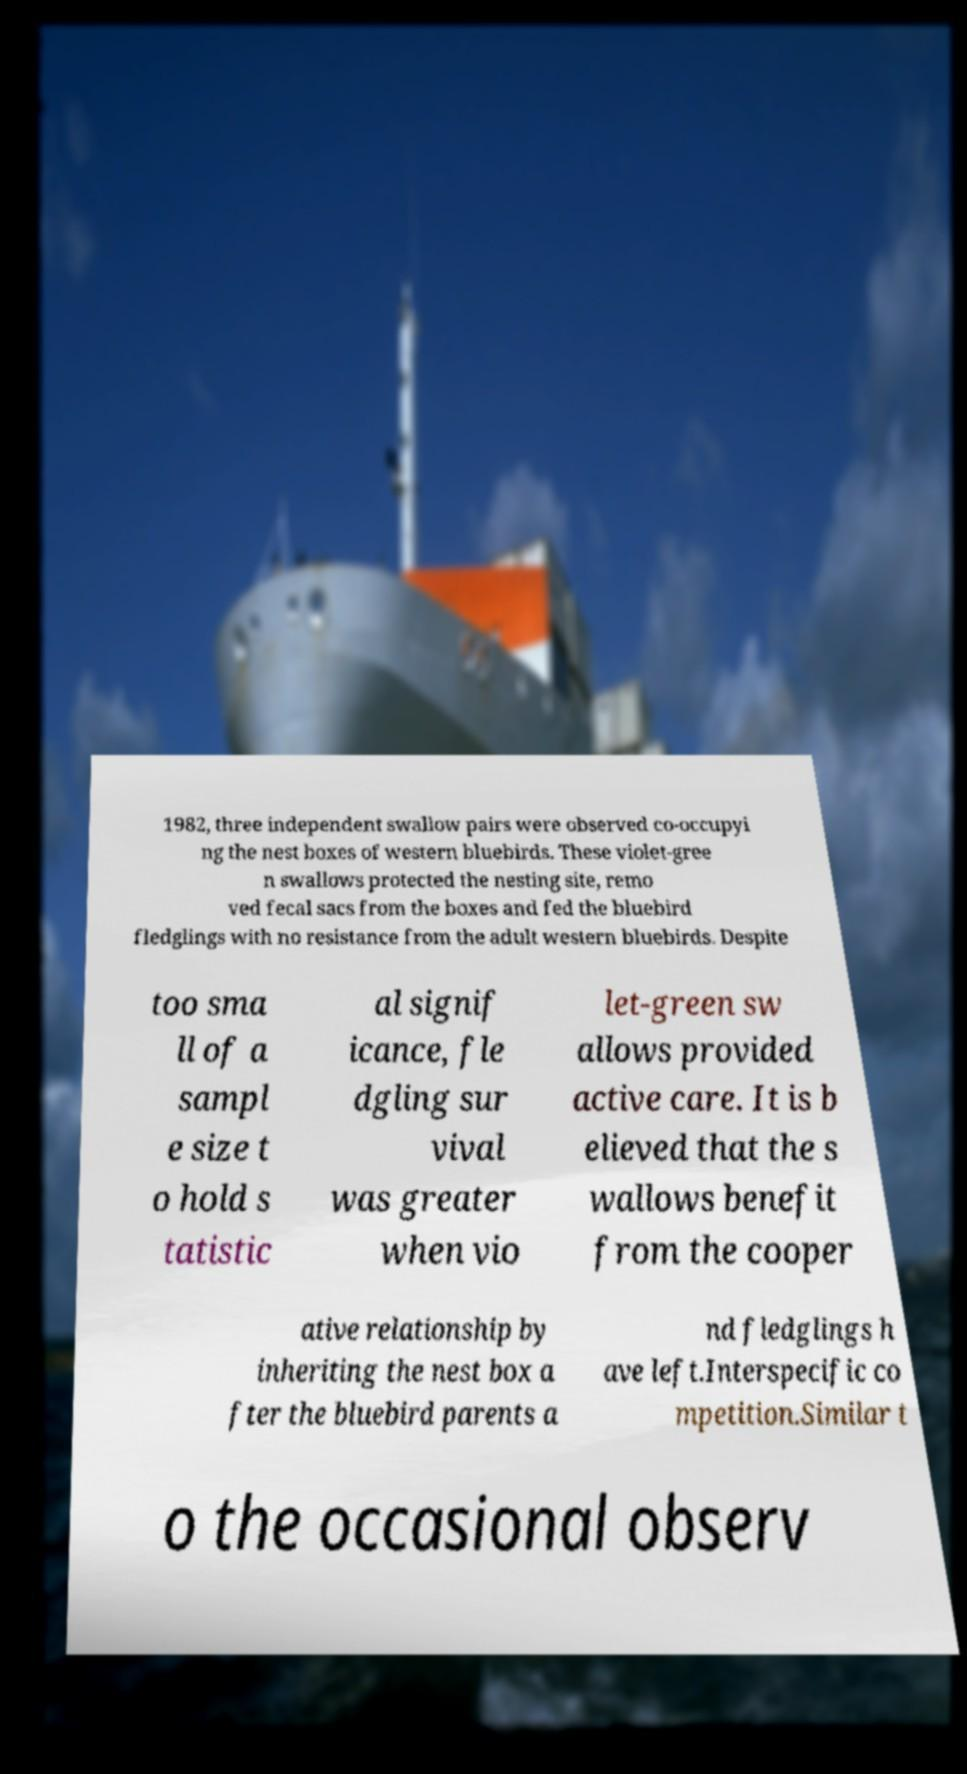Please read and relay the text visible in this image. What does it say? 1982, three independent swallow pairs were observed co-occupyi ng the nest boxes of western bluebirds. These violet-gree n swallows protected the nesting site, remo ved fecal sacs from the boxes and fed the bluebird fledglings with no resistance from the adult western bluebirds. Despite too sma ll of a sampl e size t o hold s tatistic al signif icance, fle dgling sur vival was greater when vio let-green sw allows provided active care. It is b elieved that the s wallows benefit from the cooper ative relationship by inheriting the nest box a fter the bluebird parents a nd fledglings h ave left.Interspecific co mpetition.Similar t o the occasional observ 